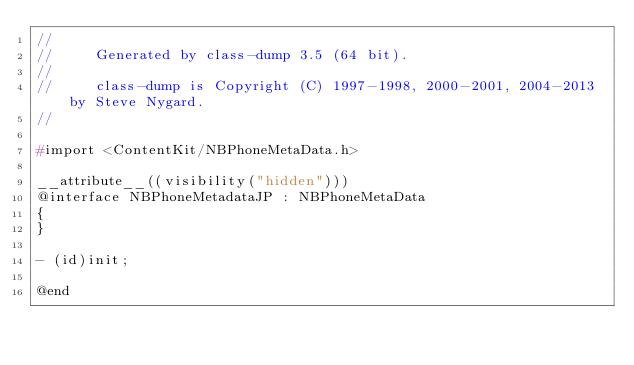Convert code to text. <code><loc_0><loc_0><loc_500><loc_500><_C_>//
//     Generated by class-dump 3.5 (64 bit).
//
//     class-dump is Copyright (C) 1997-1998, 2000-2001, 2004-2013 by Steve Nygard.
//

#import <ContentKit/NBPhoneMetaData.h>

__attribute__((visibility("hidden")))
@interface NBPhoneMetadataJP : NBPhoneMetaData
{
}

- (id)init;

@end

</code> 